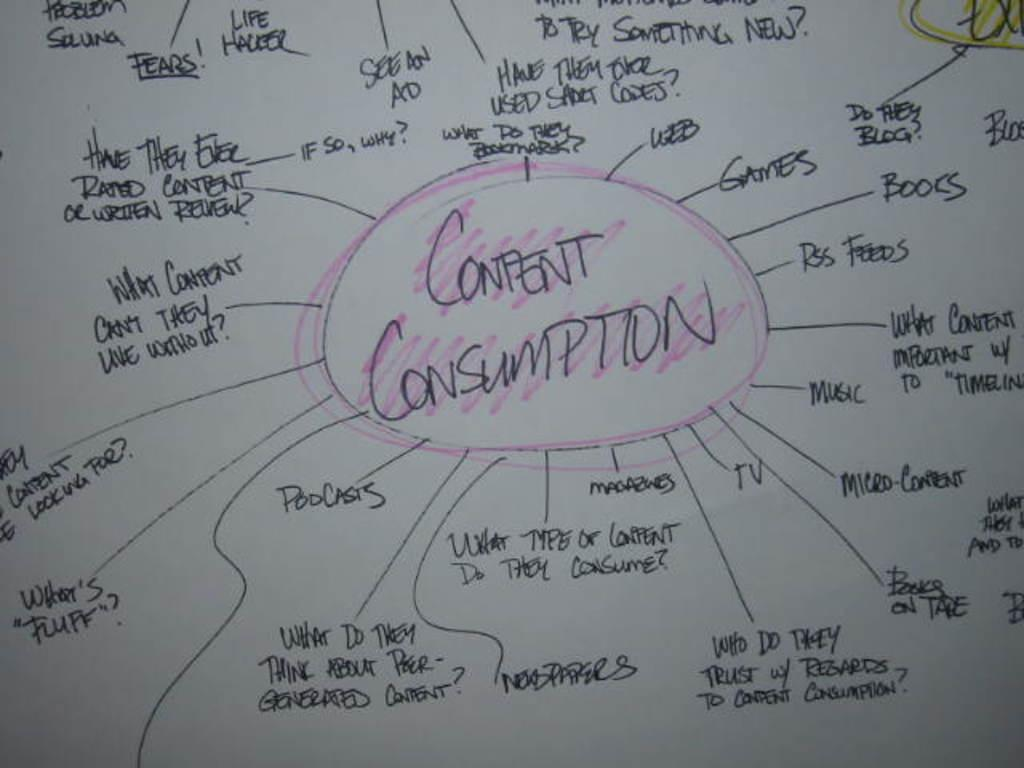Provide a one-sentence caption for the provided image. Graph or chart that has the words "Content Consumption" in the middle and colored in pink. 